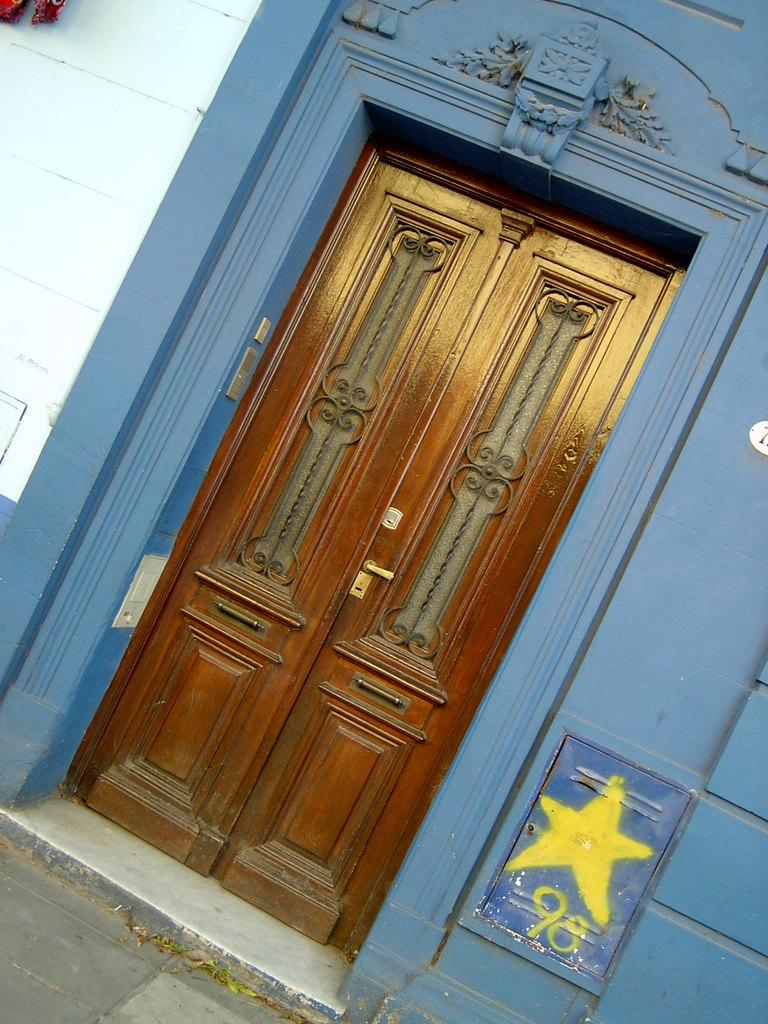What type of structure is visible in the image? There is a building in the image. Can you describe the doors of the building? The doors of the building are closed. What type of toothbrush is hanging on the wall inside the building? There is no toothbrush visible in the image, as it only shows the exterior of the building with closed doors. 